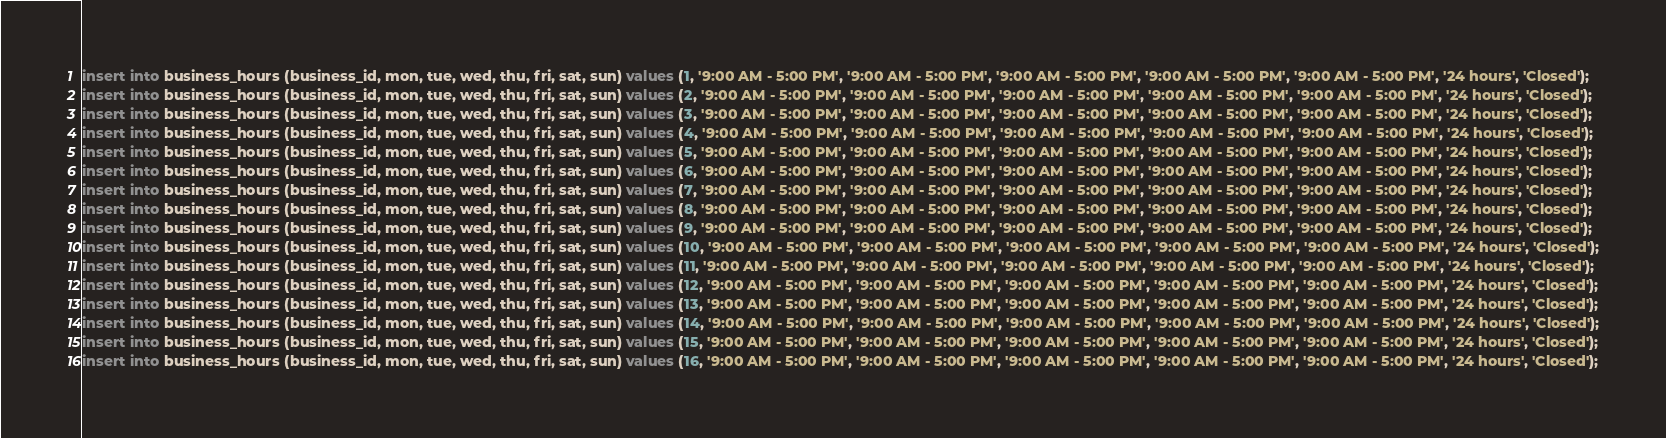Convert code to text. <code><loc_0><loc_0><loc_500><loc_500><_SQL_>insert into business_hours (business_id, mon, tue, wed, thu, fri, sat, sun) values (1, '9:00 AM - 5:00 PM', '9:00 AM - 5:00 PM', '9:00 AM - 5:00 PM', '9:00 AM - 5:00 PM', '9:00 AM - 5:00 PM', '24 hours', 'Closed');
insert into business_hours (business_id, mon, tue, wed, thu, fri, sat, sun) values (2, '9:00 AM - 5:00 PM', '9:00 AM - 5:00 PM', '9:00 AM - 5:00 PM', '9:00 AM - 5:00 PM', '9:00 AM - 5:00 PM', '24 hours', 'Closed');
insert into business_hours (business_id, mon, tue, wed, thu, fri, sat, sun) values (3, '9:00 AM - 5:00 PM', '9:00 AM - 5:00 PM', '9:00 AM - 5:00 PM', '9:00 AM - 5:00 PM', '9:00 AM - 5:00 PM', '24 hours', 'Closed');
insert into business_hours (business_id, mon, tue, wed, thu, fri, sat, sun) values (4, '9:00 AM - 5:00 PM', '9:00 AM - 5:00 PM', '9:00 AM - 5:00 PM', '9:00 AM - 5:00 PM', '9:00 AM - 5:00 PM', '24 hours', 'Closed');
insert into business_hours (business_id, mon, tue, wed, thu, fri, sat, sun) values (5, '9:00 AM - 5:00 PM', '9:00 AM - 5:00 PM', '9:00 AM - 5:00 PM', '9:00 AM - 5:00 PM', '9:00 AM - 5:00 PM', '24 hours', 'Closed');
insert into business_hours (business_id, mon, tue, wed, thu, fri, sat, sun) values (6, '9:00 AM - 5:00 PM', '9:00 AM - 5:00 PM', '9:00 AM - 5:00 PM', '9:00 AM - 5:00 PM', '9:00 AM - 5:00 PM', '24 hours', 'Closed');
insert into business_hours (business_id, mon, tue, wed, thu, fri, sat, sun) values (7, '9:00 AM - 5:00 PM', '9:00 AM - 5:00 PM', '9:00 AM - 5:00 PM', '9:00 AM - 5:00 PM', '9:00 AM - 5:00 PM', '24 hours', 'Closed');
insert into business_hours (business_id, mon, tue, wed, thu, fri, sat, sun) values (8, '9:00 AM - 5:00 PM', '9:00 AM - 5:00 PM', '9:00 AM - 5:00 PM', '9:00 AM - 5:00 PM', '9:00 AM - 5:00 PM', '24 hours', 'Closed');
insert into business_hours (business_id, mon, tue, wed, thu, fri, sat, sun) values (9, '9:00 AM - 5:00 PM', '9:00 AM - 5:00 PM', '9:00 AM - 5:00 PM', '9:00 AM - 5:00 PM', '9:00 AM - 5:00 PM', '24 hours', 'Closed');
insert into business_hours (business_id, mon, tue, wed, thu, fri, sat, sun) values (10, '9:00 AM - 5:00 PM', '9:00 AM - 5:00 PM', '9:00 AM - 5:00 PM', '9:00 AM - 5:00 PM', '9:00 AM - 5:00 PM', '24 hours', 'Closed');
insert into business_hours (business_id, mon, tue, wed, thu, fri, sat, sun) values (11, '9:00 AM - 5:00 PM', '9:00 AM - 5:00 PM', '9:00 AM - 5:00 PM', '9:00 AM - 5:00 PM', '9:00 AM - 5:00 PM', '24 hours', 'Closed');
insert into business_hours (business_id, mon, tue, wed, thu, fri, sat, sun) values (12, '9:00 AM - 5:00 PM', '9:00 AM - 5:00 PM', '9:00 AM - 5:00 PM', '9:00 AM - 5:00 PM', '9:00 AM - 5:00 PM', '24 hours', 'Closed');
insert into business_hours (business_id, mon, tue, wed, thu, fri, sat, sun) values (13, '9:00 AM - 5:00 PM', '9:00 AM - 5:00 PM', '9:00 AM - 5:00 PM', '9:00 AM - 5:00 PM', '9:00 AM - 5:00 PM', '24 hours', 'Closed');
insert into business_hours (business_id, mon, tue, wed, thu, fri, sat, sun) values (14, '9:00 AM - 5:00 PM', '9:00 AM - 5:00 PM', '9:00 AM - 5:00 PM', '9:00 AM - 5:00 PM', '9:00 AM - 5:00 PM', '24 hours', 'Closed');
insert into business_hours (business_id, mon, tue, wed, thu, fri, sat, sun) values (15, '9:00 AM - 5:00 PM', '9:00 AM - 5:00 PM', '9:00 AM - 5:00 PM', '9:00 AM - 5:00 PM', '9:00 AM - 5:00 PM', '24 hours', 'Closed');
insert into business_hours (business_id, mon, tue, wed, thu, fri, sat, sun) values (16, '9:00 AM - 5:00 PM', '9:00 AM - 5:00 PM', '9:00 AM - 5:00 PM', '9:00 AM - 5:00 PM', '9:00 AM - 5:00 PM', '24 hours', 'Closed');</code> 